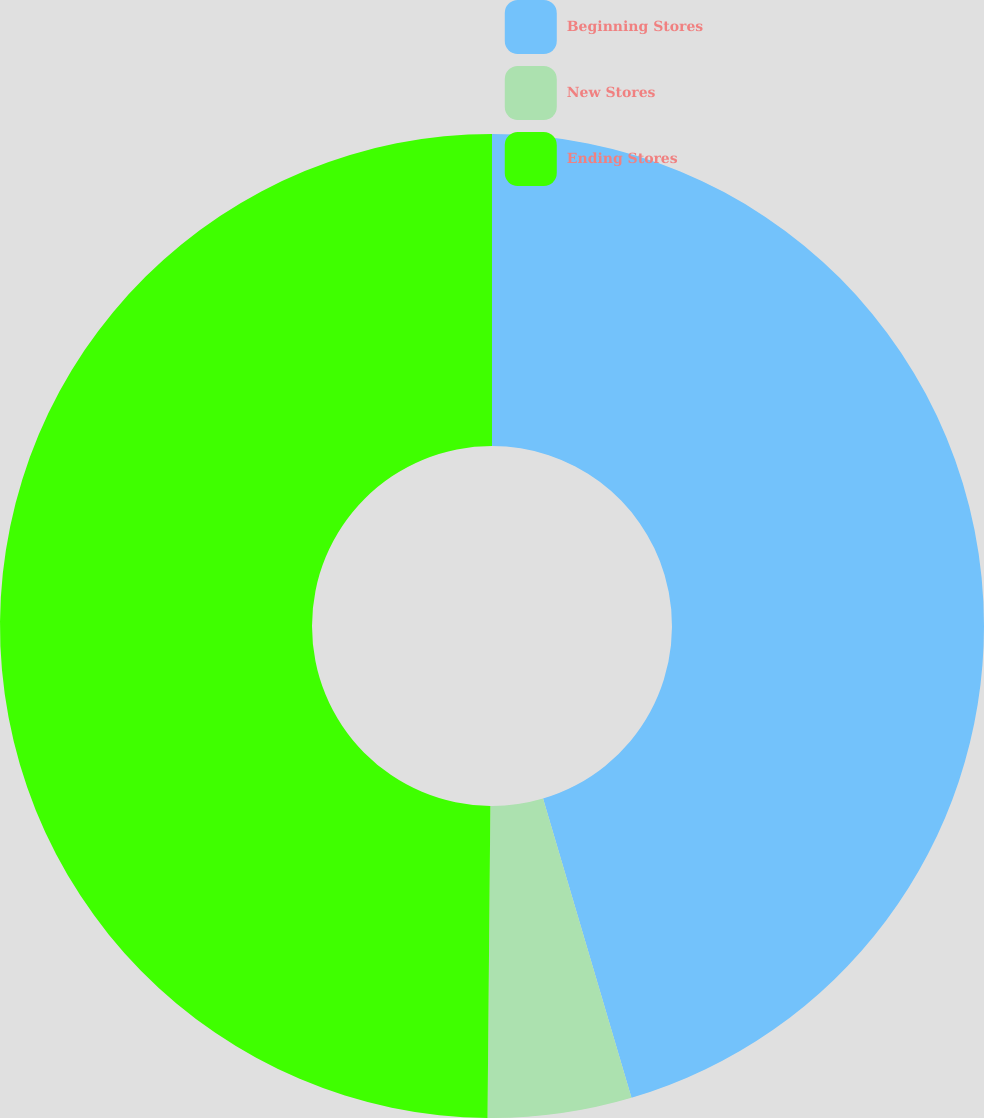Convert chart. <chart><loc_0><loc_0><loc_500><loc_500><pie_chart><fcel>Beginning Stores<fcel>New Stores<fcel>Ending Stores<nl><fcel>45.42%<fcel>4.72%<fcel>49.85%<nl></chart> 